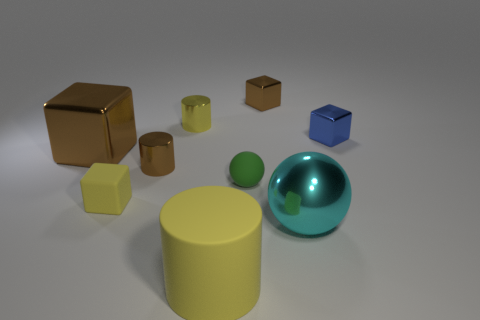Add 1 large shiny blocks. How many objects exist? 10 Subtract all balls. How many objects are left? 7 Subtract 0 brown balls. How many objects are left? 9 Subtract all tiny shiny objects. Subtract all red rubber cylinders. How many objects are left? 5 Add 2 brown cylinders. How many brown cylinders are left? 3 Add 5 large green metal spheres. How many large green metal spheres exist? 5 